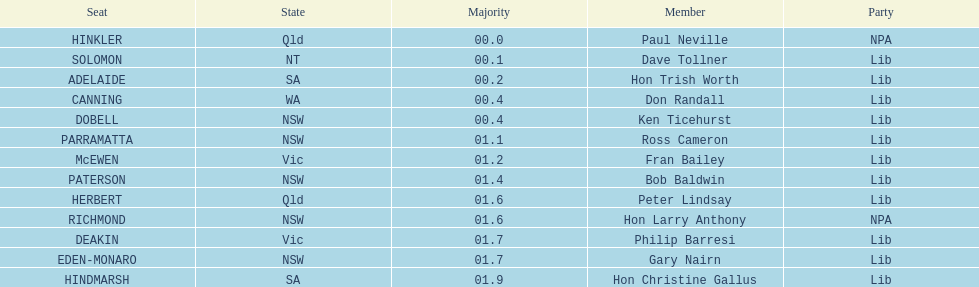What is the difference in majority between hindmarsh and hinkler? 01.9. 